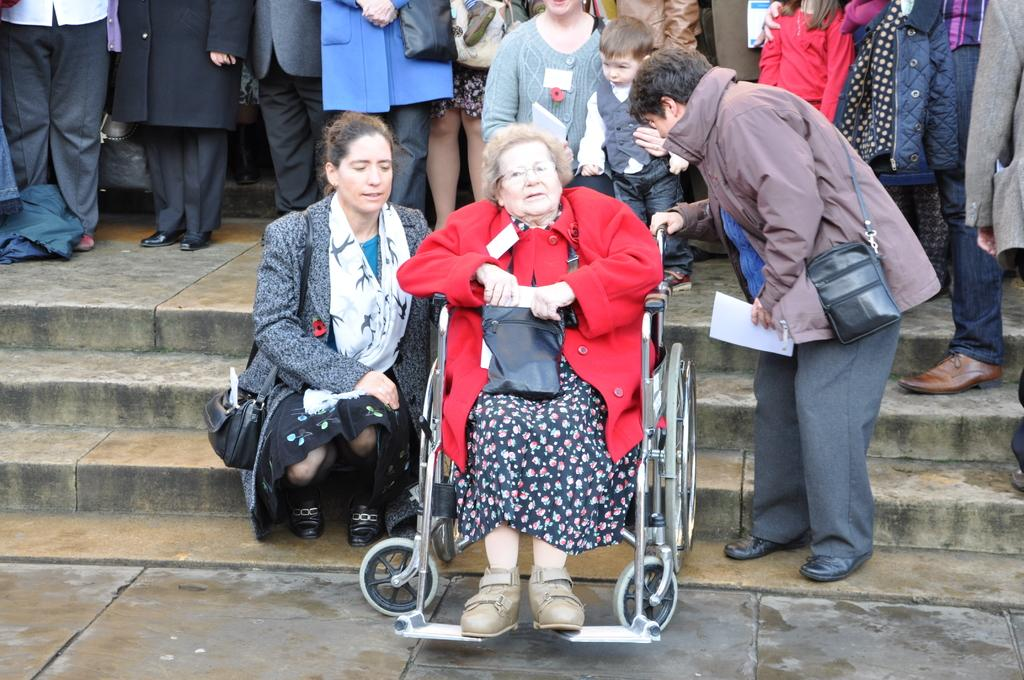How many people are in the image? There are people in the image, but the exact number is not specified. What are some people doing in the image? Some people are holding objects, and some are sitting. What is visible on the ground in the image? Wheelchairs and stairs are visible on the ground. What type of surface is the ground in the image? The ground is visible in the image, but its specific type is not mentioned. What color is the cloth draped over the stomach of the person playing volleyball in the image? There is no person playing volleyball or cloth draped over a stomach in the image. 